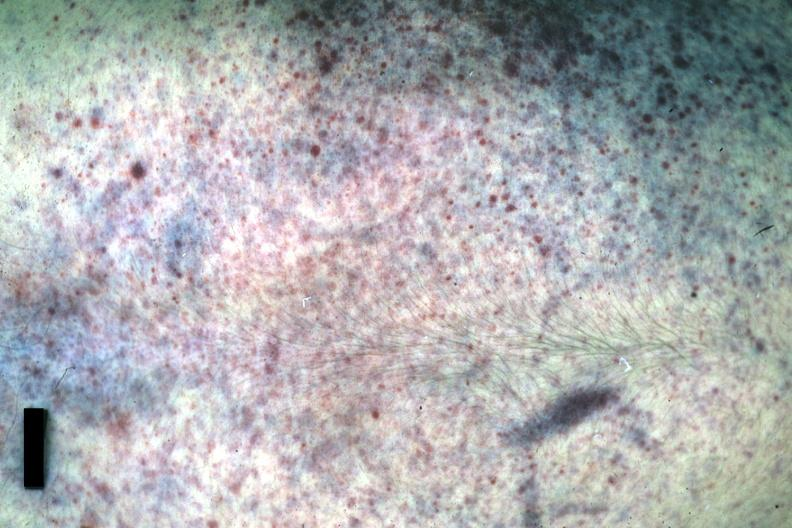does vasculature show good example either chest was anterior or posterior?
Answer the question using a single word or phrase. No 